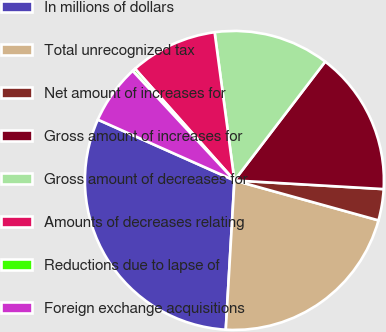<chart> <loc_0><loc_0><loc_500><loc_500><pie_chart><fcel>In millions of dollars<fcel>Total unrecognized tax<fcel>Net amount of increases for<fcel>Gross amount of increases for<fcel>Gross amount of decreases for<fcel>Amounts of decreases relating<fcel>Reductions due to lapse of<fcel>Foreign exchange acquisitions<nl><fcel>30.75%<fcel>21.62%<fcel>3.38%<fcel>15.54%<fcel>12.5%<fcel>9.46%<fcel>0.34%<fcel>6.42%<nl></chart> 